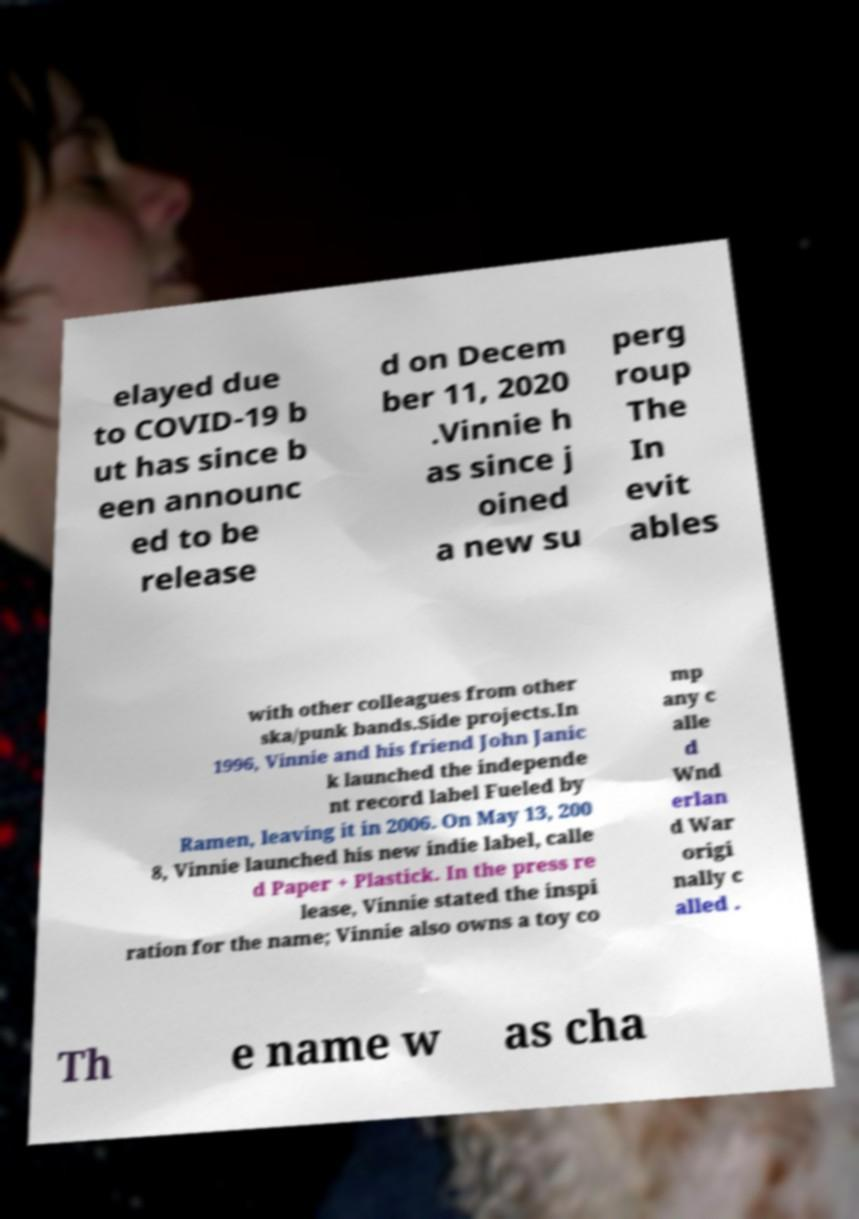Could you assist in decoding the text presented in this image and type it out clearly? elayed due to COVID-19 b ut has since b een announc ed to be release d on Decem ber 11, 2020 .Vinnie h as since j oined a new su perg roup The In evit ables with other colleagues from other ska/punk bands.Side projects.In 1996, Vinnie and his friend John Janic k launched the independe nt record label Fueled by Ramen, leaving it in 2006. On May 13, 200 8, Vinnie launched his new indie label, calle d Paper + Plastick. In the press re lease, Vinnie stated the inspi ration for the name; Vinnie also owns a toy co mp any c alle d Wnd erlan d War origi nally c alled . Th e name w as cha 